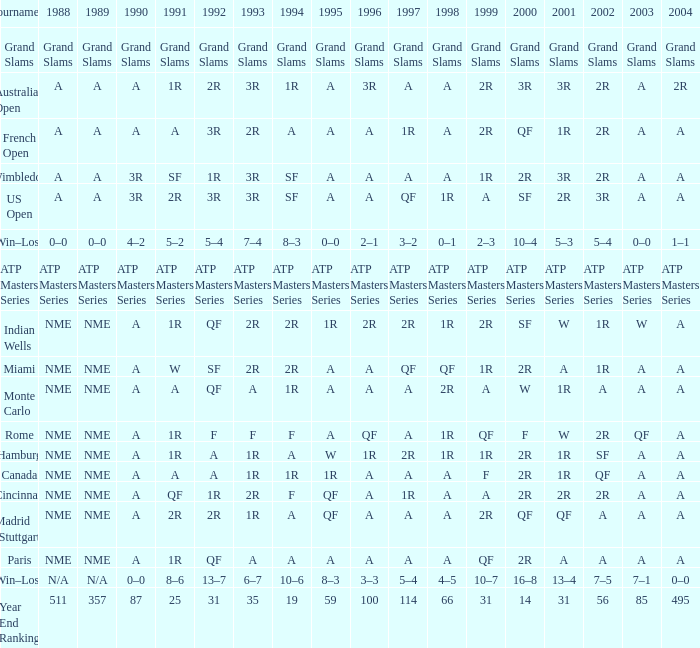What is presented for 1988 when 1994 demonstrates 10-6? N/A. 